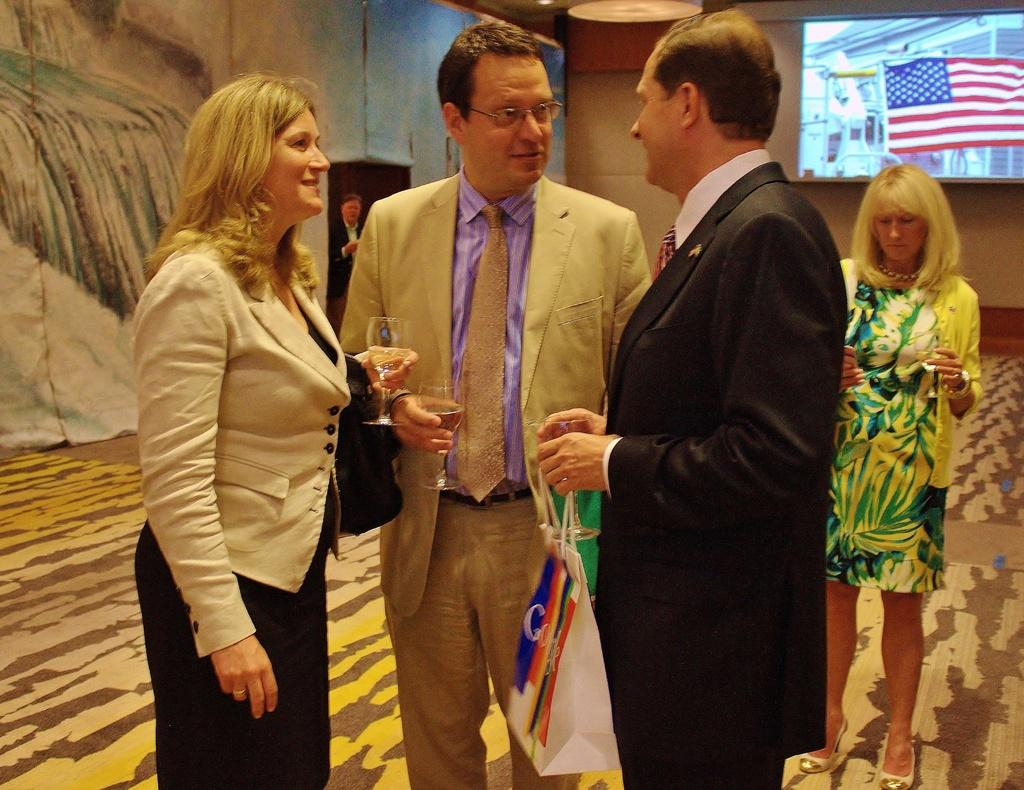How many people are present in the image? There are four persons standing in the image. What are the four persons holding in their hands? The four persons are holding wine glasses. What can be seen in the background of the image? There is a screen and another person standing in the background of the image, along with some objects. What type of toothbrush is the person in the background using in the image? There is no toothbrush present in the image; the person in the background is not using any such object. 